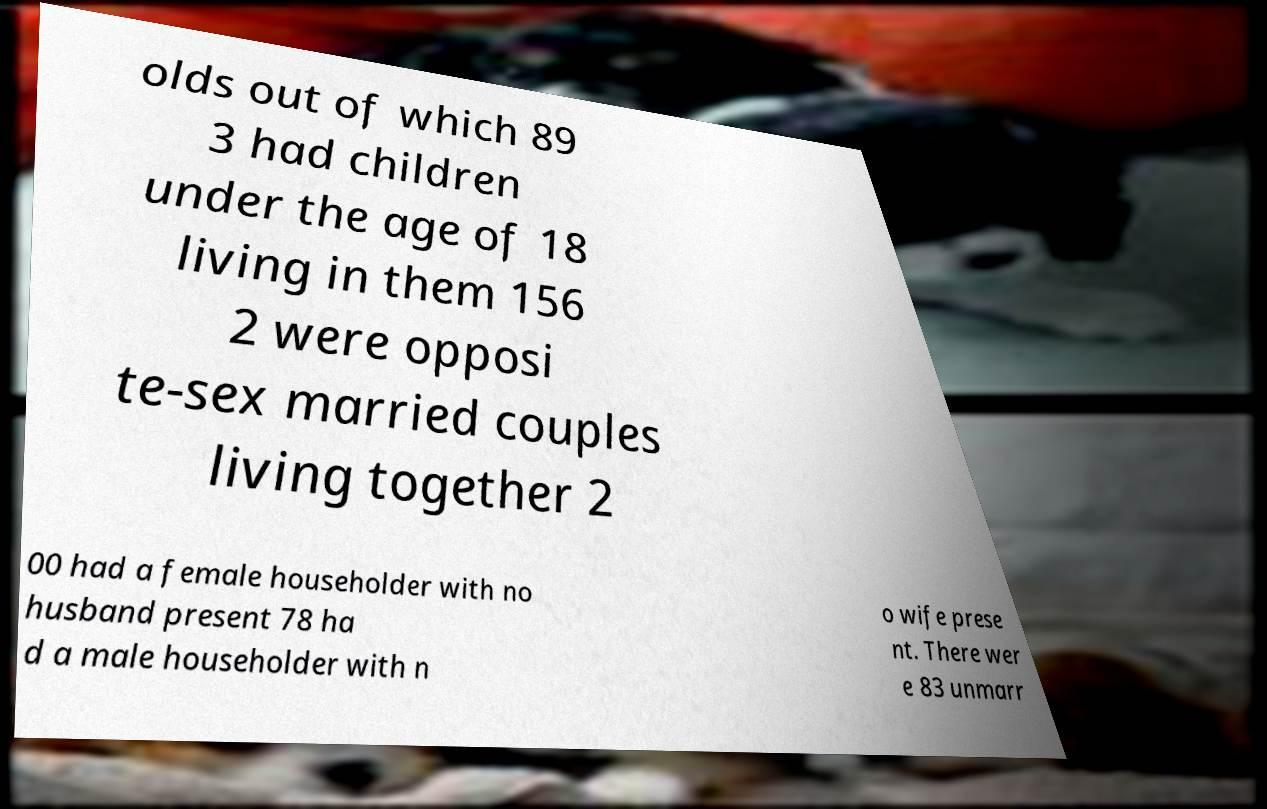For documentation purposes, I need the text within this image transcribed. Could you provide that? olds out of which 89 3 had children under the age of 18 living in them 156 2 were opposi te-sex married couples living together 2 00 had a female householder with no husband present 78 ha d a male householder with n o wife prese nt. There wer e 83 unmarr 